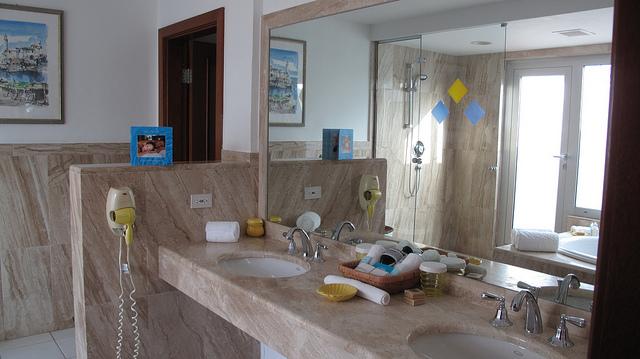Do you see diamonds?
Keep it brief. Yes. Where are the windows?
Write a very short answer. In mirror. Is this a large bathroom?
Write a very short answer. Yes. Is there running water in the sink?
Answer briefly. No. Is there a shadow cast?
Answer briefly. No. Where is the hair dryer?
Answer briefly. On wall. Have they finished remodeling?
Be succinct. Yes. 